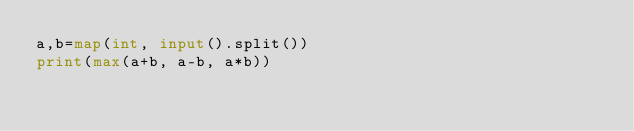Convert code to text. <code><loc_0><loc_0><loc_500><loc_500><_Python_>a,b=map(int, input().split())
print(max(a+b, a-b, a*b))</code> 